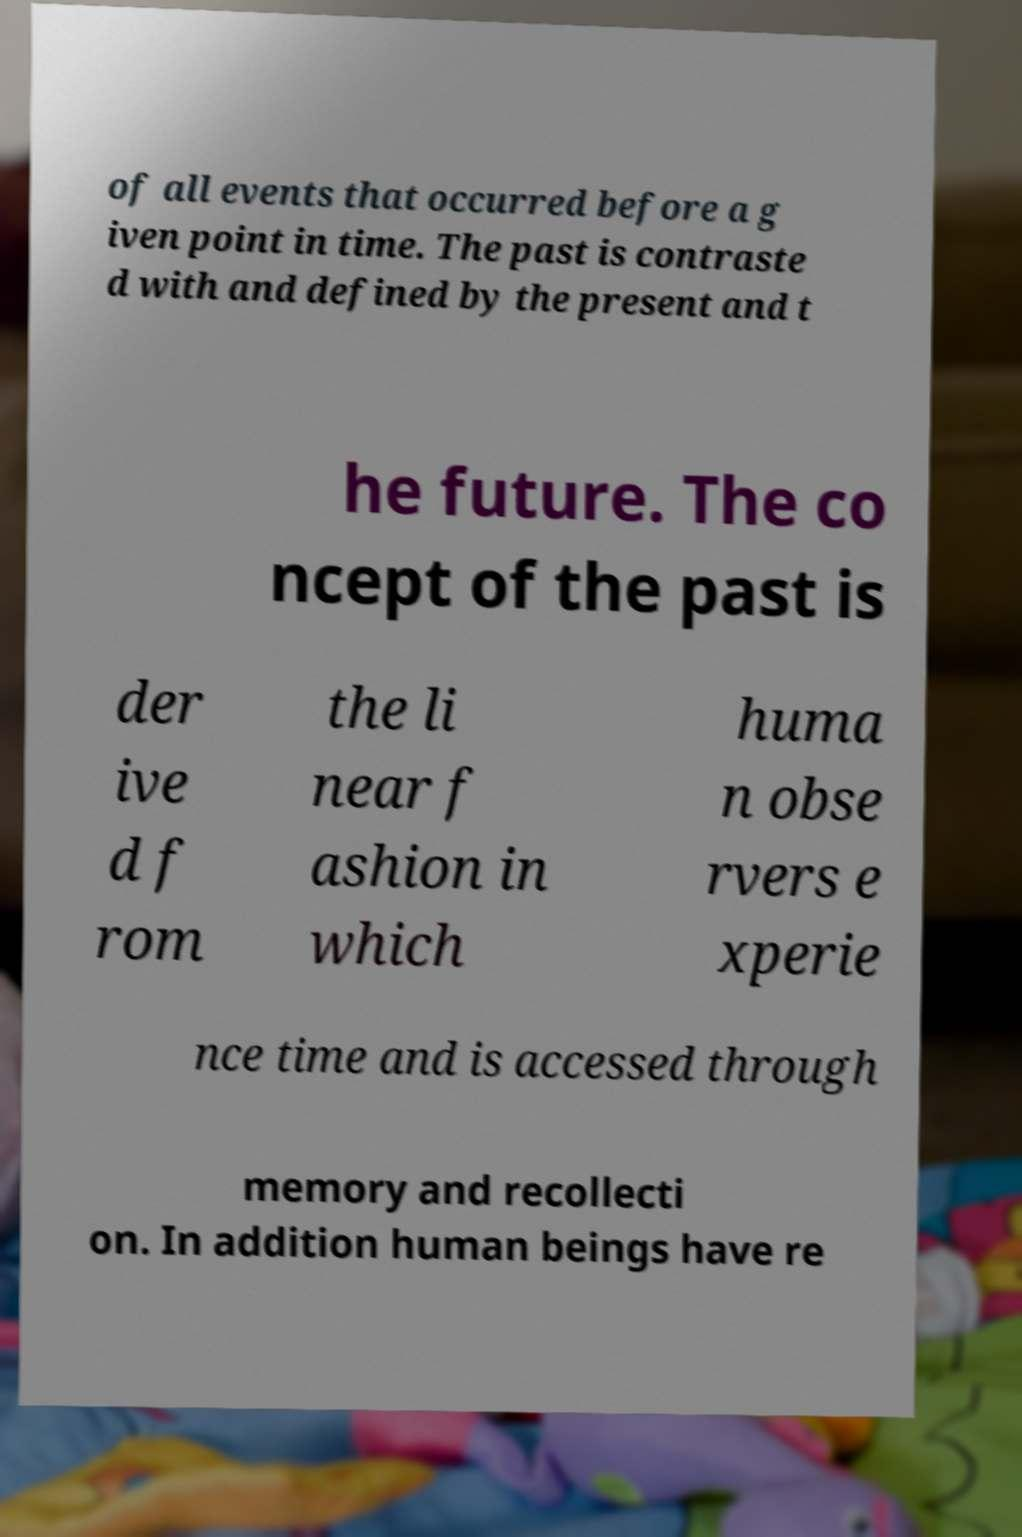Could you assist in decoding the text presented in this image and type it out clearly? of all events that occurred before a g iven point in time. The past is contraste d with and defined by the present and t he future. The co ncept of the past is der ive d f rom the li near f ashion in which huma n obse rvers e xperie nce time and is accessed through memory and recollecti on. In addition human beings have re 